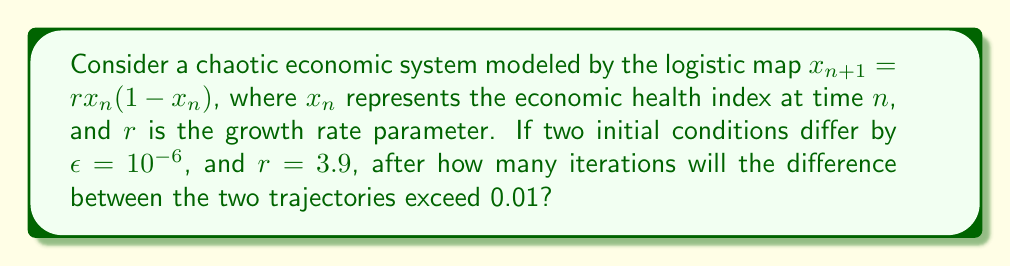Could you help me with this problem? To solve this problem, we need to understand the concept of sensitivity to initial conditions in chaotic systems. Let's approach this step-by-step:

1) The logistic map is given by $x_{n+1} = rx_n(1-x_n)$, with $r = 3.9$.

2) For chaotic systems, the difference between two nearby trajectories grows exponentially on average:

   $d_n \approx \epsilon e^{\lambda n}$

   where $d_n$ is the difference after $n$ iterations, $\epsilon$ is the initial difference, and $\lambda$ is the Lyapunov exponent.

3) For the logistic map with $r = 3.9$, the Lyapunov exponent is approximately $\lambda \approx 0.6$.

4) We want to find $n$ when $d_n > 0.01$. Let's set up the equation:

   $10^{-6} e^{0.6n} > 0.01$

5) Taking the natural log of both sides:

   $\ln(10^{-6}) + 0.6n > \ln(0.01)$

6) Simplify:

   $-13.82 + 0.6n > -4.61$

7) Solve for $n$:

   $0.6n > 9.21$
   $n > 15.35$

8) Since $n$ must be an integer, we round up to the next whole number.
Answer: 16 iterations 